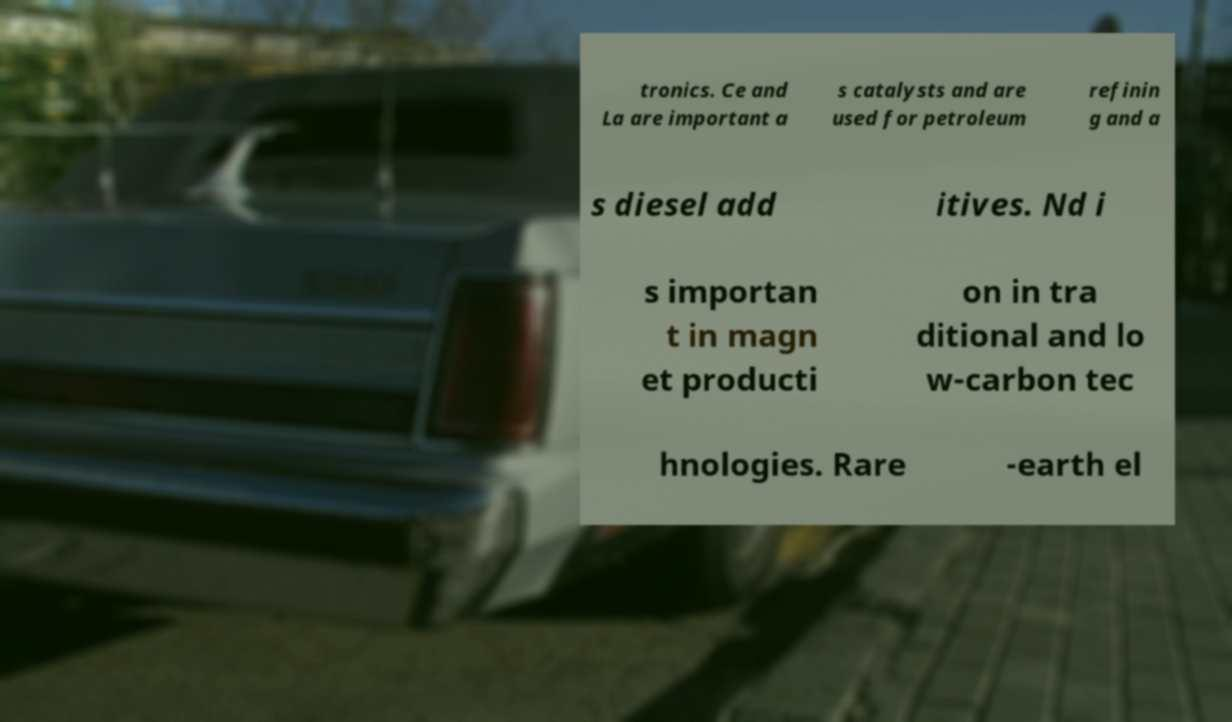Could you assist in decoding the text presented in this image and type it out clearly? tronics. Ce and La are important a s catalysts and are used for petroleum refinin g and a s diesel add itives. Nd i s importan t in magn et producti on in tra ditional and lo w-carbon tec hnologies. Rare -earth el 